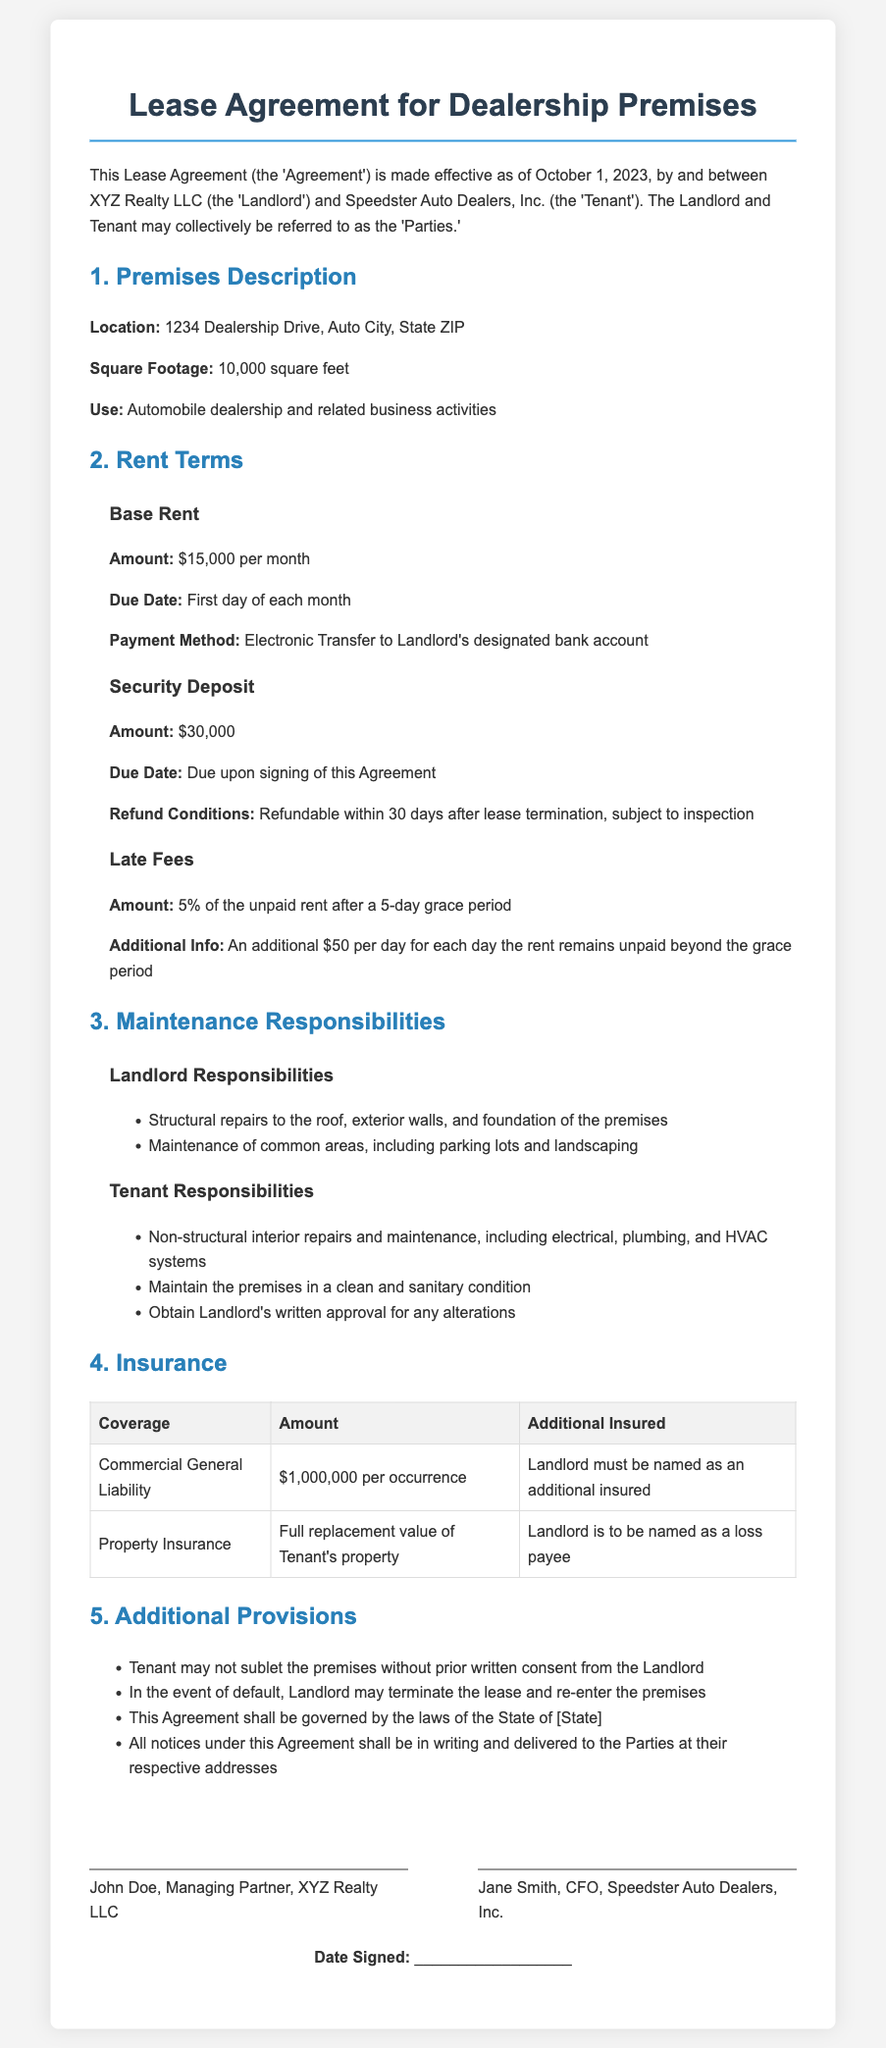What is the effective date of the Lease Agreement? The effective date of the Lease Agreement is specified in the document as October 1, 2023.
Answer: October 1, 2023 What is the monthly rent amount? The monthly rent amount is clearly stated in the Rent Terms section as $15,000.
Answer: $15,000 What is the security deposit due upon signing? The security deposit amount required upon signing of the Agreement is explicitly mentioned as $30,000.
Answer: $30,000 Who is responsible for maintaining common areas? The document specifies that the Landlord is responsible for the maintenance of common areas including parking lots and landscaping.
Answer: Landlord What is the percentage of late fee after a grace period? The percentage of the late fee after the 5-day grace period is detailed in the Rent Terms as 5%.
Answer: 5% What must the Tenant obtain for alterations? The document states that the Tenant must obtain the Landlord's written approval for any alterations.
Answer: Written approval What type of insurance must the Tenant have? The required type of insurance for the Tenant is mentioned in the Insurance section as Commercial General Liability.
Answer: Commercial General Liability What is the total square footage of the premises? The square footage of the premises is provided in the Premises Description section as 10,000 square feet.
Answer: 10,000 square feet What are the conditions for refunding the security deposit? The refund conditions for the security deposit are specified as refundable within 30 days after lease termination, subject to inspection.
Answer: Refundable within 30 days after lease termination, subject to inspection 